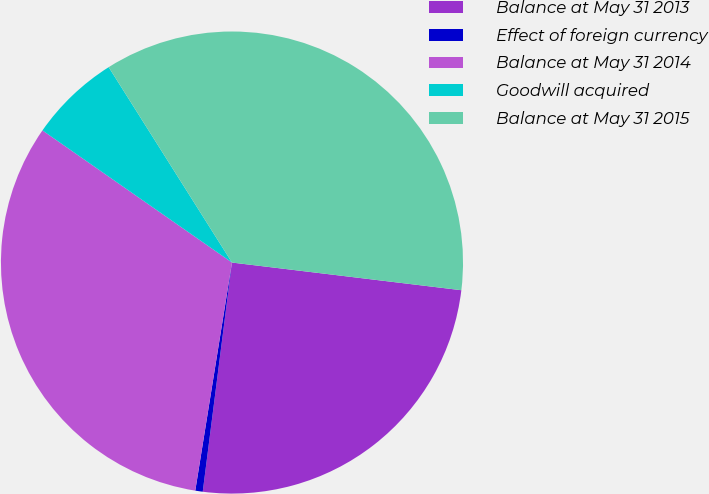<chart> <loc_0><loc_0><loc_500><loc_500><pie_chart><fcel>Balance at May 31 2013<fcel>Effect of foreign currency<fcel>Balance at May 31 2014<fcel>Goodwill acquired<fcel>Balance at May 31 2015<nl><fcel>25.11%<fcel>0.52%<fcel>32.15%<fcel>6.35%<fcel>35.87%<nl></chart> 